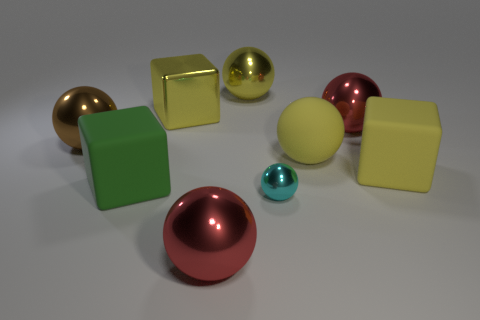Is there anything else that has the same size as the cyan shiny object?
Ensure brevity in your answer.  No. Do the yellow ball in front of the metallic cube and the cube behind the brown thing have the same material?
Offer a very short reply. No. How many blocks are either tiny objects or shiny things?
Provide a short and direct response. 1. There is a tiny metallic sphere that is in front of the red metallic object to the right of the yellow metal ball; how many big yellow blocks are on the right side of it?
Ensure brevity in your answer.  1. There is a big metal object that is in front of the brown ball; what color is it?
Your answer should be very brief. Red. Is the small ball made of the same material as the red sphere that is in front of the tiny cyan ball?
Your response must be concise. Yes. What material is the small cyan object?
Your answer should be very brief. Metal. There is a large brown object that is made of the same material as the cyan sphere; what shape is it?
Your answer should be compact. Sphere. What number of other objects are there of the same shape as the large green object?
Keep it short and to the point. 2. What number of big yellow blocks are to the right of the small cyan object?
Ensure brevity in your answer.  1. 